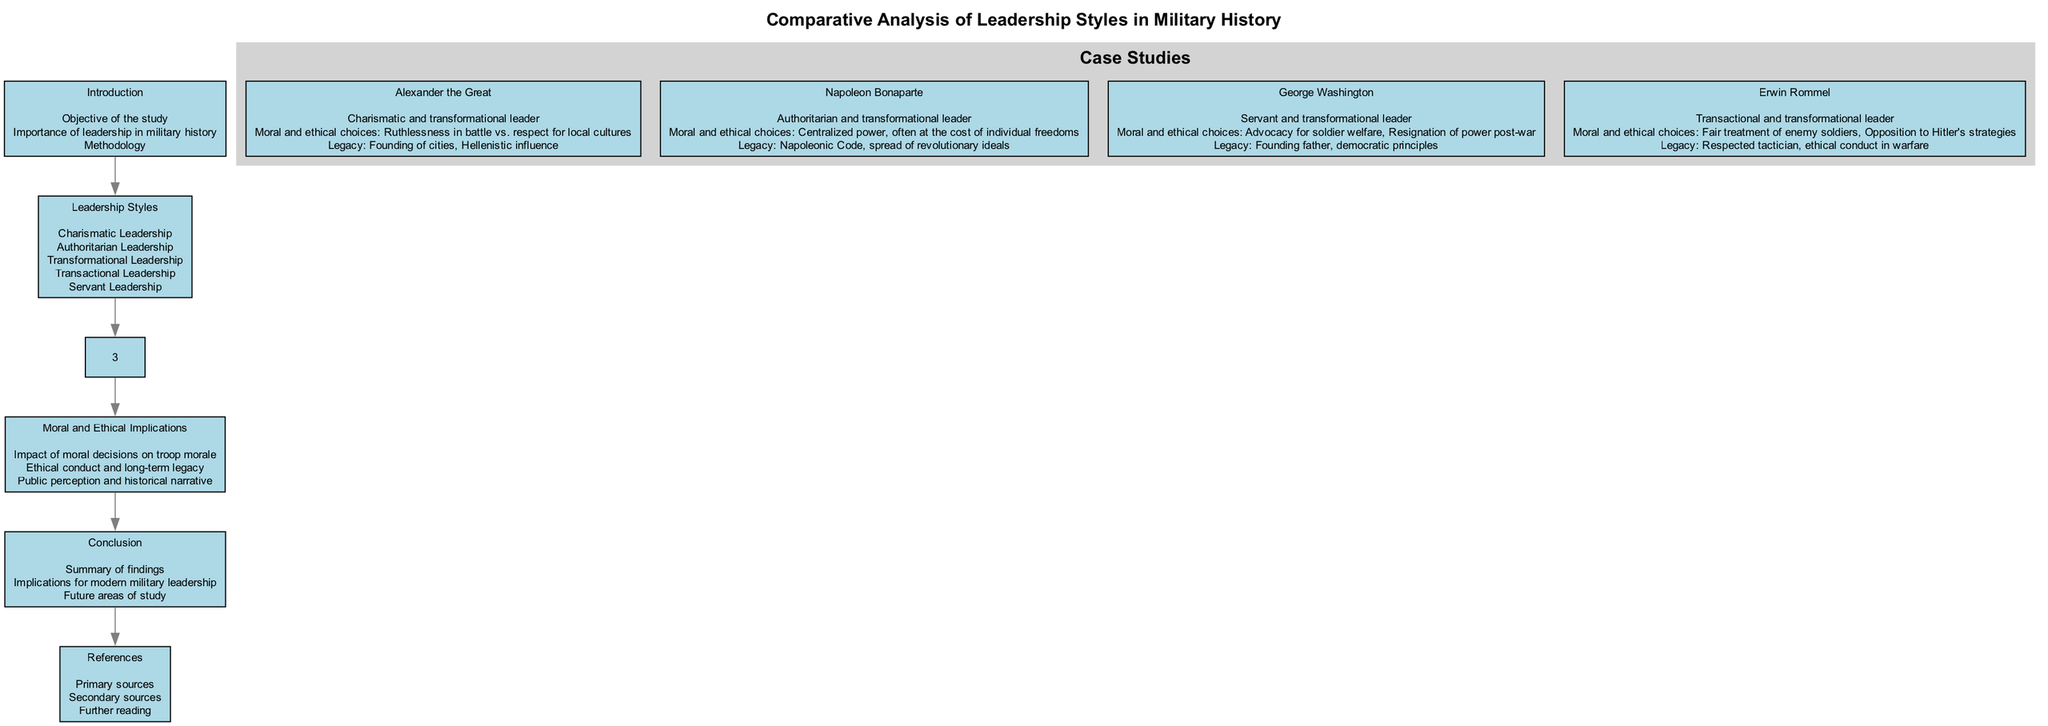What is the title of the diagram? The title of the diagram can be found at the top section of the block diagram and is labeled as “Comparative Analysis of Leadership Styles in Military History.”
Answer: Comparative Analysis of Leadership Styles in Military History How many main blocks are in the diagram? By counting the distinct main blocks listed, we can identify a total of six main blocks: Introduction, Leadership Styles, Case Studies, Moral and Ethical Implications, Conclusion, and References.
Answer: 6 What leadership style is associated with George Washington? The block labeled "George Washington" specifically indicates that he embodies the "Servant and transformational leader" styles.
Answer: Servant and transformational leader Which military leader is described as an authoritarian and transformational leader? From the "Case Studies" block, we can specifically identify Napoleon Bonaparte as the leader characterized by authoritarian and transformational leadership styles.
Answer: Napoleon Bonaparte What are the moral choices mentioned for Erwin Rommel? The details associated with the block for Erwin Rommel highlight his moral and ethical choices such as "Fair treatment of enemy soldiers" and "Opposition to Hitler's strategies."
Answer: Fair treatment of enemy soldiers, Opposition to Hitler's strategies What is the legacy of Alexander the Great? The block detailing Alexander the Great notes his legacy, which includes "Founding of cities" and "Hellenistic influence," illustrating the long-term impacts of his leadership.
Answer: Founding of cities, Hellenistic influence How does the diagram depict the relationship between moral decisions and troop morale? In the "Moral and Ethical Implications" block, it explicitly states that the impact of moral decisions directly influences "troop morale," emphasizing the critical importance of these choices.
Answer: Impact of moral decisions on troop morale How many case studies are presented in the diagram? Upon examining the sections under the "Case Studies" block, we can count four distinct military leaders discussed: Alexander the Great, Napoleon Bonaparte, George Washington, and Erwin Rommel.
Answer: 4 What is the final block in the diagram? The block that appears last in the diagram is labeled "References," indicating that it provides sources to support the study.
Answer: References 